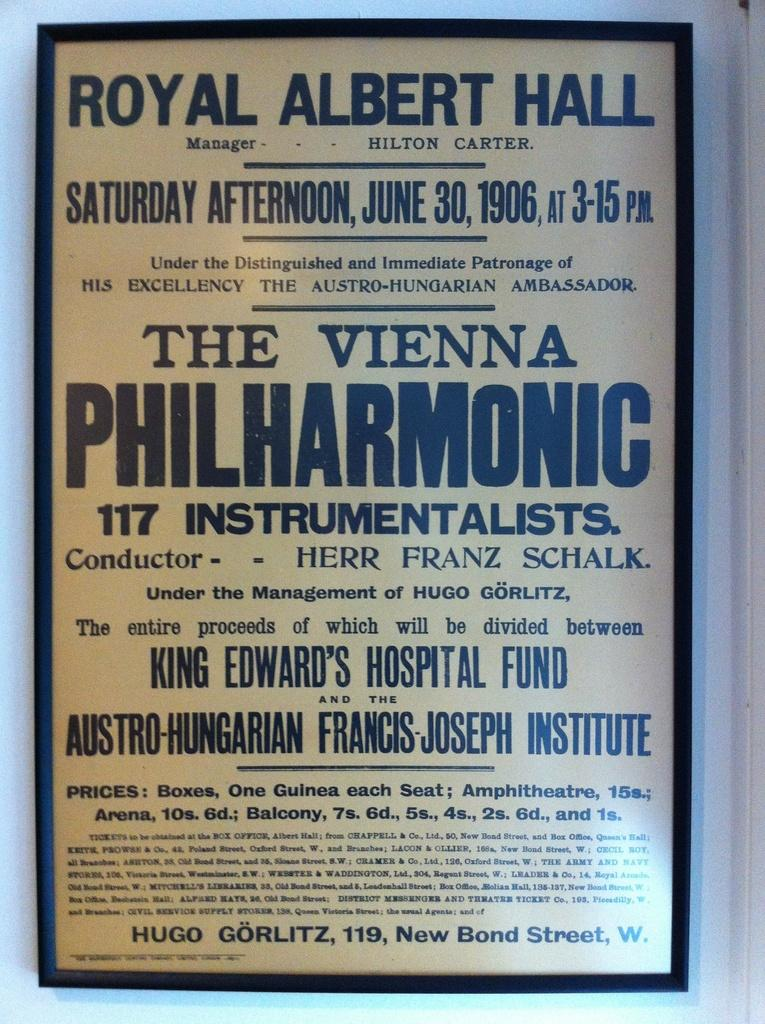<image>
Share a concise interpretation of the image provided. A poster reads "Royal Albert Hall" at the top. 